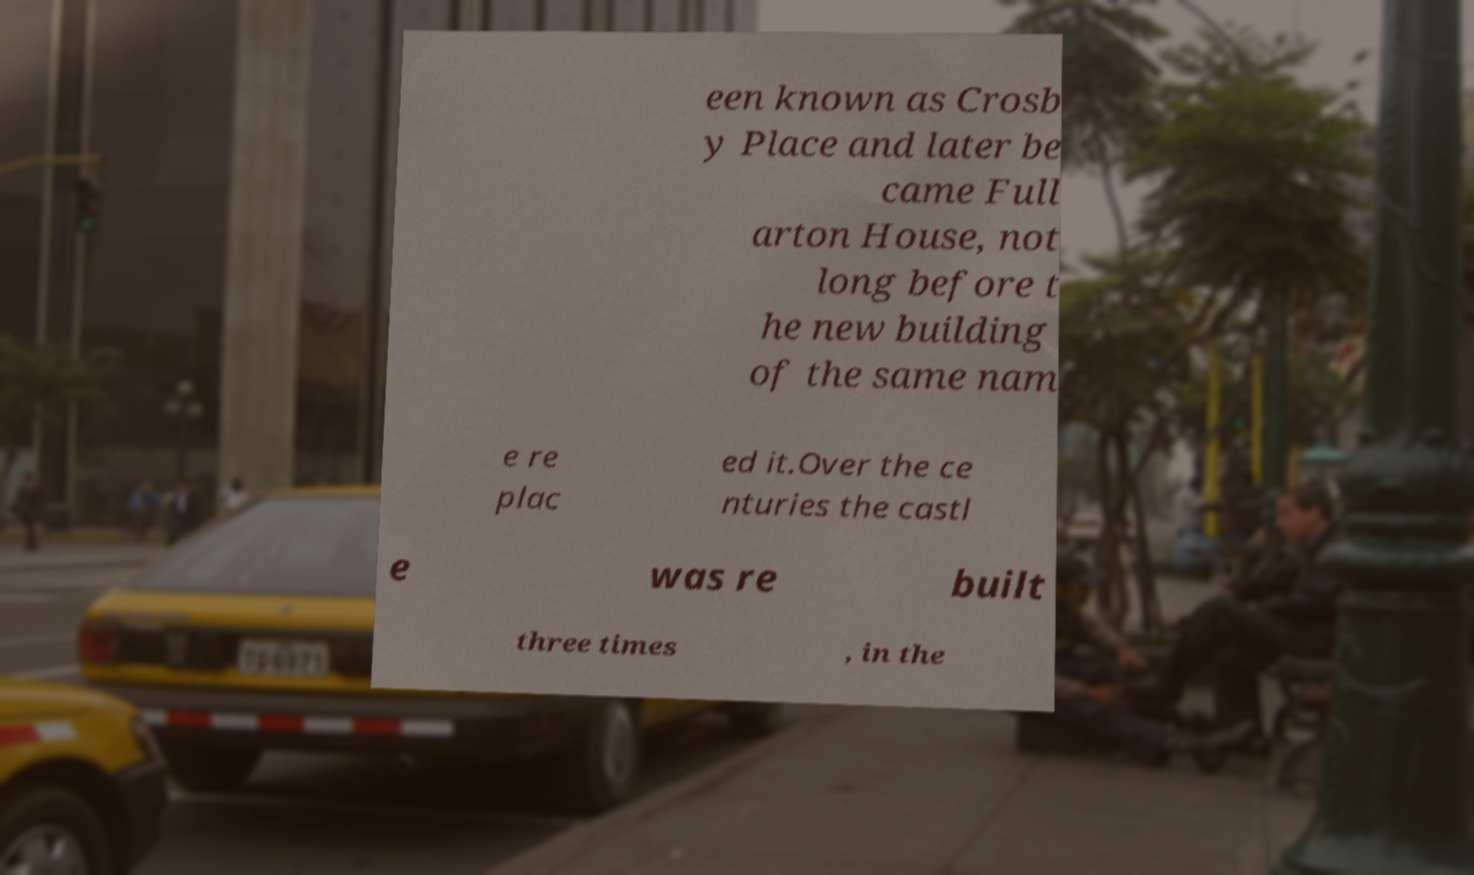Can you accurately transcribe the text from the provided image for me? een known as Crosb y Place and later be came Full arton House, not long before t he new building of the same nam e re plac ed it.Over the ce nturies the castl e was re built three times , in the 